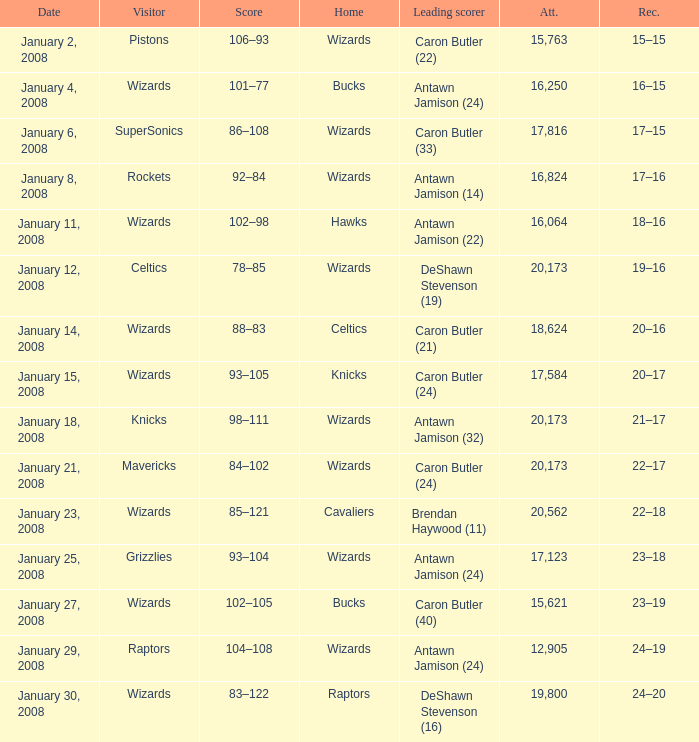Can you parse all the data within this table? {'header': ['Date', 'Visitor', 'Score', 'Home', 'Leading scorer', 'Att.', 'Rec.'], 'rows': [['January 2, 2008', 'Pistons', '106–93', 'Wizards', 'Caron Butler (22)', '15,763', '15–15'], ['January 4, 2008', 'Wizards', '101–77', 'Bucks', 'Antawn Jamison (24)', '16,250', '16–15'], ['January 6, 2008', 'SuperSonics', '86–108', 'Wizards', 'Caron Butler (33)', '17,816', '17–15'], ['January 8, 2008', 'Rockets', '92–84', 'Wizards', 'Antawn Jamison (14)', '16,824', '17–16'], ['January 11, 2008', 'Wizards', '102–98', 'Hawks', 'Antawn Jamison (22)', '16,064', '18–16'], ['January 12, 2008', 'Celtics', '78–85', 'Wizards', 'DeShawn Stevenson (19)', '20,173', '19–16'], ['January 14, 2008', 'Wizards', '88–83', 'Celtics', 'Caron Butler (21)', '18,624', '20–16'], ['January 15, 2008', 'Wizards', '93–105', 'Knicks', 'Caron Butler (24)', '17,584', '20–17'], ['January 18, 2008', 'Knicks', '98–111', 'Wizards', 'Antawn Jamison (32)', '20,173', '21–17'], ['January 21, 2008', 'Mavericks', '84–102', 'Wizards', 'Caron Butler (24)', '20,173', '22–17'], ['January 23, 2008', 'Wizards', '85–121', 'Cavaliers', 'Brendan Haywood (11)', '20,562', '22–18'], ['January 25, 2008', 'Grizzlies', '93–104', 'Wizards', 'Antawn Jamison (24)', '17,123', '23–18'], ['January 27, 2008', 'Wizards', '102–105', 'Bucks', 'Caron Butler (40)', '15,621', '23–19'], ['January 29, 2008', 'Raptors', '104–108', 'Wizards', 'Antawn Jamison (24)', '12,905', '24–19'], ['January 30, 2008', 'Wizards', '83–122', 'Raptors', 'DeShawn Stevenson (16)', '19,800', '24–20']]} How many people were in attendance on January 4, 2008? 16250.0. 